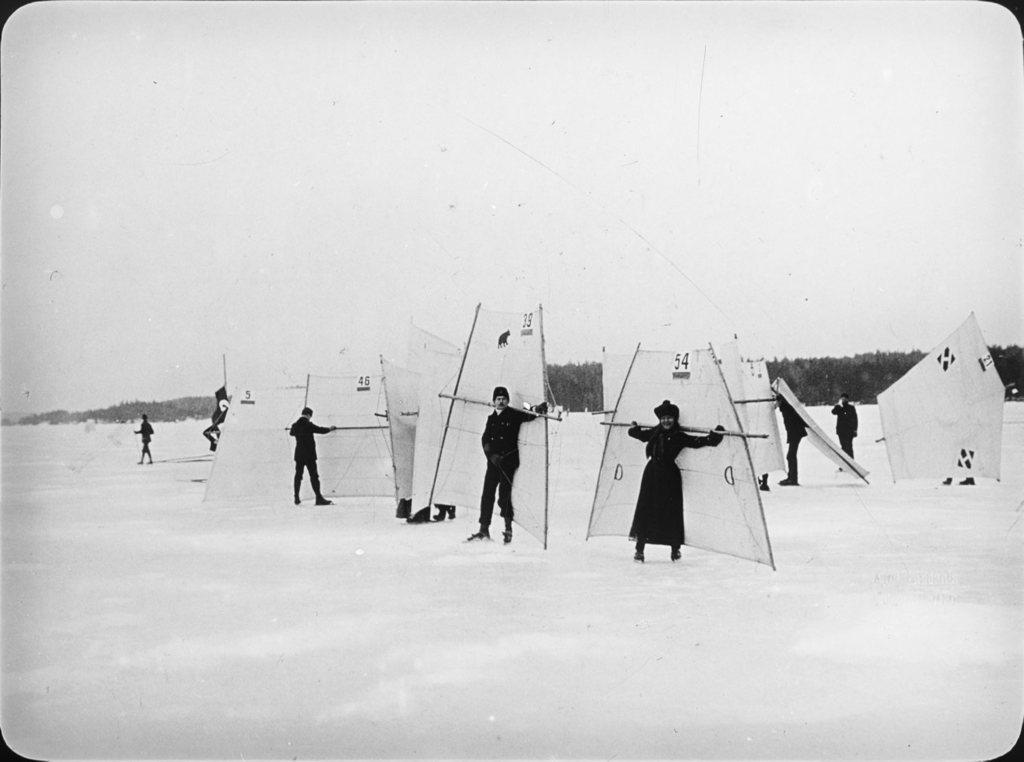Please provide a concise description of this image. In this image, we can see few people on the snow. They are doing sail skiing. Background we can see trees and sky. 